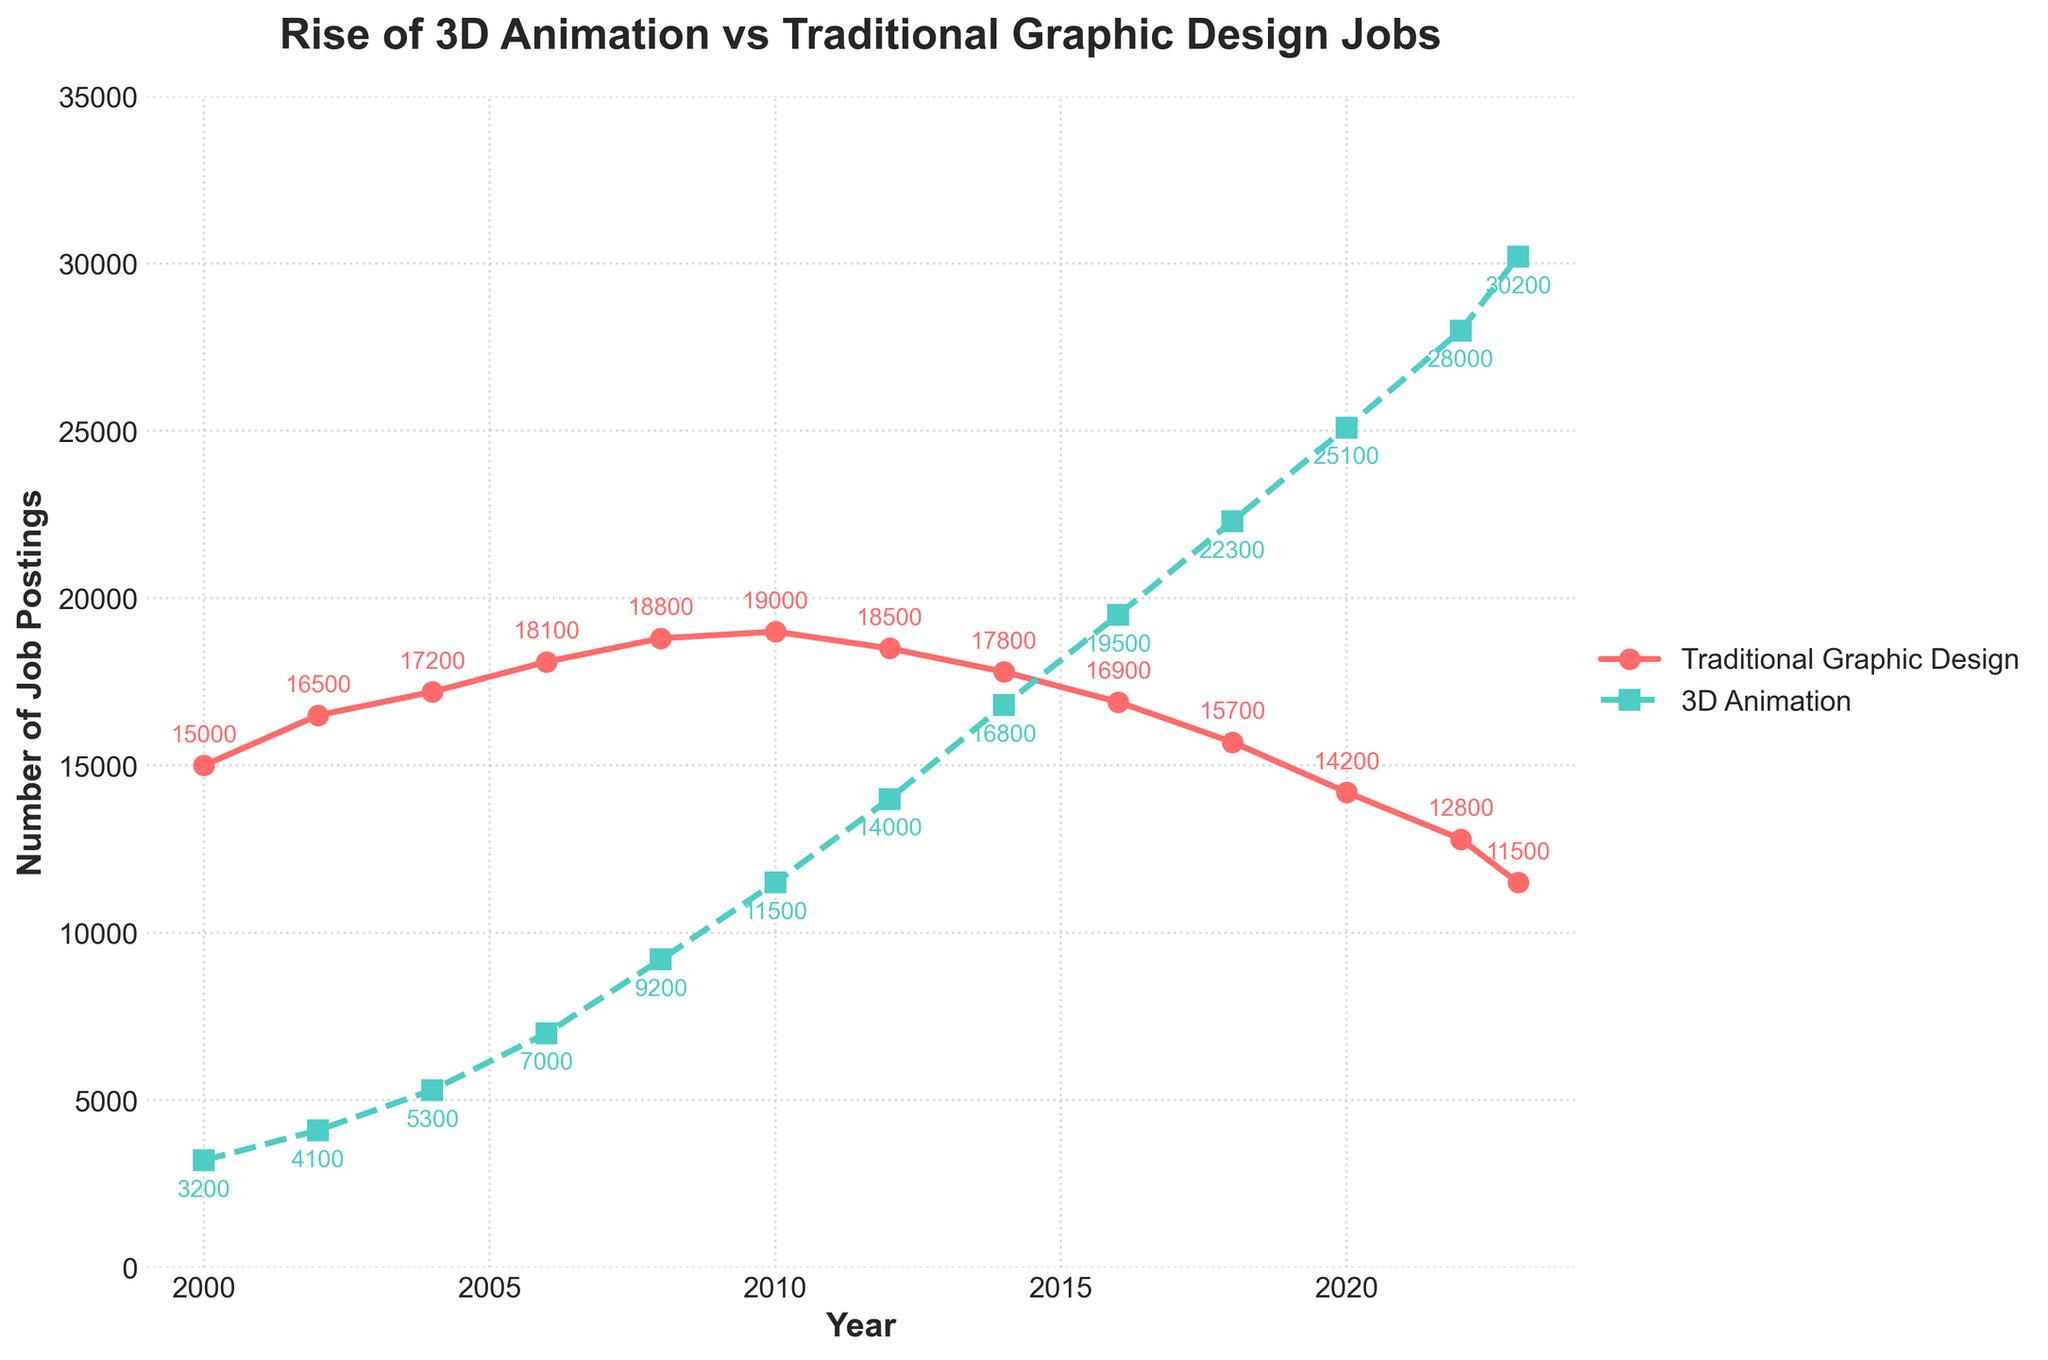What is the overall trend for Traditional Graphic Design job postings from 2000 to 2023? The number of Traditional Graphic Design job postings steadily decreases from 2000 to 2023. This can be observed by the downward slope of the red line representing these jobs on the chart. In 2000, there were 15,000 job postings, whereas in 2023, there are only 11,500.
Answer: Steady decline By how much did 3D Animation job postings increase from 2000 to 2023? To calculate this, subtract the number of 3D Animation job postings in 2000 from the number in 2023. In 2000, there were 3,200 job postings, and in 2023, there are 30,200 job postings. So, the increase is 30,200 - 3,200.
Answer: 27,000 Which year shows the highest number of Traditional Graphic Design job postings? The year with the highest number of job postings is identified by the highest point on the red line representing Traditional Graphic Design jobs. From the figure, 2010 has the highest point with 19,000 job postings.
Answer: 2010 In which year did 3D Animation job postings surpass Traditional Graphic Design job postings? Locate the point where the green line representing 3D Animation jobs crosses the red line representing Traditional Graphic Design jobs. From the figure, this crossover happens between 2010 and 2012, but 2012 distinctly shows 14,000 Traditional jobs vs. 14,000 3D jobs.
Answer: 2012 How much higher were 3D Animation job postings compared to Traditional Graphic Design job postings in 2023? To find this, subtract the number of Traditional Graphic Design job postings in 2023 from the number of 3D Animation job postings in 2023. This is 30,200 - 11,500.
Answer: 18,700 What is the general movement of 3D Animation job postings from 2000 to 2023? The number of 3D Animation job postings shows a steady upward trend from 2000 to 2023. The green line representing these jobs is consistently rising, indicating growth.
Answer: Steady increase Between which years did Traditional Graphic Design job postings start to decline? Identify the years around when the red line representing Traditional Graphic Design job postings starts to slope downwards steadily. It starts declining prominently after 2010 when it reduces from 19,000 to lower values in subsequent years.
Answer: Post-2010 Calculate the overall percentage decrease in Traditional Graphic Design job postings from 2000 to 2023. First, determine the decrease: 15,000 (2000) to 11,500 (2023) is a drop of 3,500. Then, calculate the percentage decrease: (3,500 / 15,000) * 100%.
Answer: 23.3% Describe how the visual elements (color, line style, marker) distinguish between the two types of job postings. The figure uses different colors, line styles, and markers to distinguish between job postings. Traditional Graphic Design jobs are shown in red with a solid line and circular markers, while 3D Animation jobs are in green with a dashed line and square markers. These visual differences make it easy to differentiate between the two data series.
Answer: Different colors and styles Compare the number of job postings for both fields in 2010. Which had more job postings, and by how much? In 2010, Traditional Graphic Design had 19,000 job postings, and 3D Animation had 11,500 job postings. Subtract 11,500 from 19,000 to find that Traditional Graphic Design had 7,500 more job postings in 2010.
Answer: Traditional Graphic Design by 7,500 